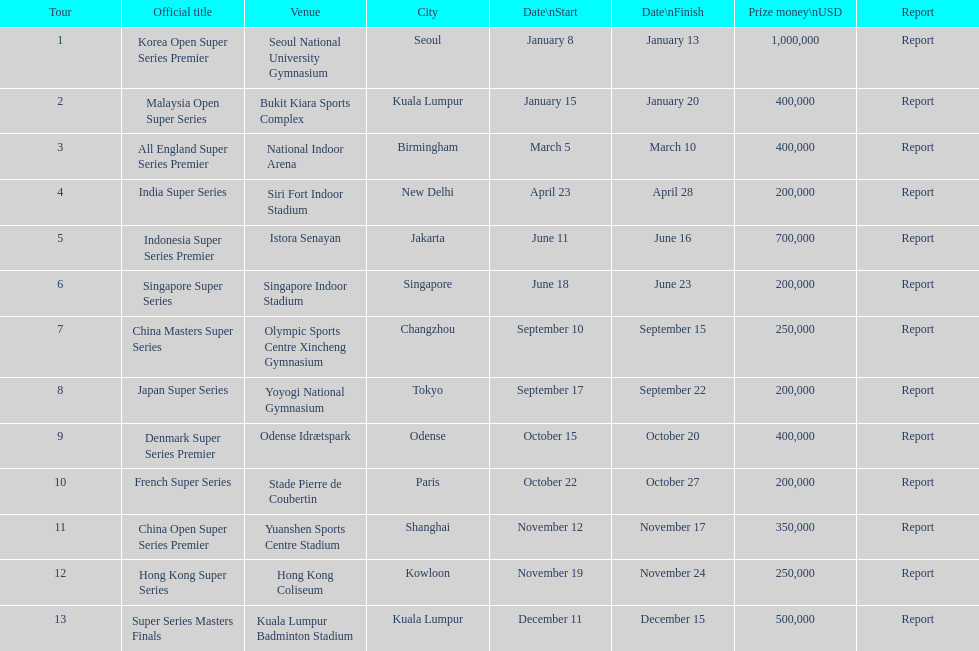What were the designations of the 2013 bwf super series? Korea Open Super Series Premier, Malaysia Open Super Series, All England Super Series Premier, India Super Series, Indonesia Super Series Premier, Singapore Super Series, China Masters Super Series, Japan Super Series, Denmark Super Series Premier, French Super Series, China Open Super Series Premier, Hong Kong Super Series, Super Series Masters Finals. Can you give me this table as a dict? {'header': ['Tour', 'Official title', 'Venue', 'City', 'Date\\nStart', 'Date\\nFinish', 'Prize money\\nUSD', 'Report'], 'rows': [['1', 'Korea Open Super Series Premier', 'Seoul National University Gymnasium', 'Seoul', 'January 8', 'January 13', '1,000,000', 'Report'], ['2', 'Malaysia Open Super Series', 'Bukit Kiara Sports Complex', 'Kuala Lumpur', 'January 15', 'January 20', '400,000', 'Report'], ['3', 'All England Super Series Premier', 'National Indoor Arena', 'Birmingham', 'March 5', 'March 10', '400,000', 'Report'], ['4', 'India Super Series', 'Siri Fort Indoor Stadium', 'New Delhi', 'April 23', 'April 28', '200,000', 'Report'], ['5', 'Indonesia Super Series Premier', 'Istora Senayan', 'Jakarta', 'June 11', 'June 16', '700,000', 'Report'], ['6', 'Singapore Super Series', 'Singapore Indoor Stadium', 'Singapore', 'June 18', 'June 23', '200,000', 'Report'], ['7', 'China Masters Super Series', 'Olympic Sports Centre Xincheng Gymnasium', 'Changzhou', 'September 10', 'September 15', '250,000', 'Report'], ['8', 'Japan Super Series', 'Yoyogi National Gymnasium', 'Tokyo', 'September 17', 'September 22', '200,000', 'Report'], ['9', 'Denmark Super Series Premier', 'Odense Idrætspark', 'Odense', 'October 15', 'October 20', '400,000', 'Report'], ['10', 'French Super Series', 'Stade Pierre de Coubertin', 'Paris', 'October 22', 'October 27', '200,000', 'Report'], ['11', 'China Open Super Series Premier', 'Yuanshen Sports Centre Stadium', 'Shanghai', 'November 12', 'November 17', '350,000', 'Report'], ['12', 'Hong Kong Super Series', 'Hong Kong Coliseum', 'Kowloon', 'November 19', 'November 24', '250,000', 'Report'], ['13', 'Super Series Masters Finals', 'Kuala Lumpur Badminton Stadium', 'Kuala Lumpur', 'December 11', 'December 15', '500,000', 'Report']]} Which occurred in december? Super Series Masters Finals. 